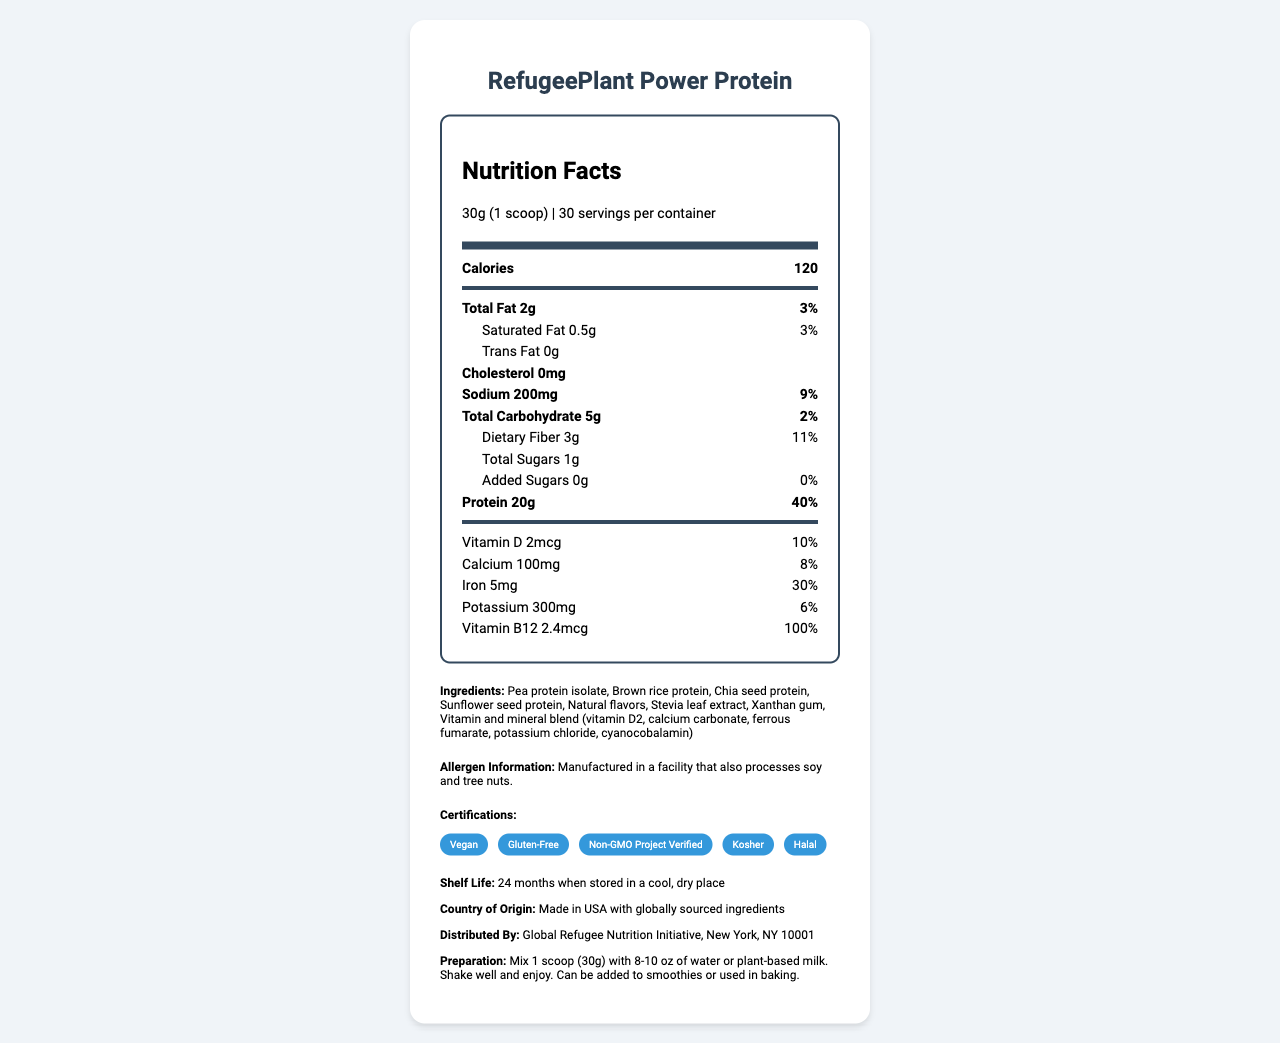what is the serving size of this product? The serving size is clearly stated at the beginning of the Nutrition Facts label.
Answer: 30g (1 scoop) how many calories does one serving contain? The calories per serving are listed right below the serving size information.
Answer: 120 what is the total fat content per serving? The total fat amount is shown directly under the Total Fat label on the Nutrition Facts section.
Answer: 2g which ingredient is listed first in the ingredients list? Pea protein isolate appears first in the list of ingredients.
Answer: Pea protein isolate what percentage of daily value (%DV) does the protein content represent? The daily value percentage for protein is specified next to its amount in the Nutrition Facts section.
Answer: 40% how much dietary fiber is in one serving? The amount of dietary fiber per serving is listed in the Nutrition Facts label.
Answer: 3g does this product contain any cholesterol? (Yes/No) The Nutrition Facts label explicitly states "Cholesterol 0mg".
Answer: No which vitamin has the highest daily value percentage in this product? A. Vitamin D B. Iron C. Vitamin B12 D. Calcium Vitamin B12 has a 100% daily value, which is the highest among the listed vitamins and minerals.
Answer: C. Vitamin B12 what certifications does this product have? A. Vegan B. Gluten-Free C. Non-GMO D. All of the above The certification list includes Vegan, Gluten-Free, Non-GMO Project Verified, Kosher, and Halal.
Answer: D. All of the above what allergens are mentioned in the allergen information? The allergen information mentions that the product is manufactured in a facility that processes soy and tree nuts.
Answer: Soy and tree nuts what is the shelf life of this product? The additional information section states the shelf life detail.
Answer: 24 months when stored in a cool, dry place does this product contain any added sugars? (True/False) The label indicates 0g of added sugars, with 0% daily value.
Answer: False summarize the main nutritional features and additional information of RefugeePlant Power Protein. This summary covers the essential nutritional features and supporting information, highlighting its suitability for refugee dietary needs.
Answer: RefugeePlant Power Protein provides a high amount of protein (20g per serving) and contains essential vitamins and minerals like Iron and Vitamin B12. It is free from cholesterol and added sugars, low in total fat, and includes 3g of dietary fiber. The product is certified Vegan, Gluten-Free, Non-GMO, Kosher, and Halal. It has a shelf life of 24 months. This makes it an ideal option for meeting refugee dietary restrictions while ensuring nutritional adequacy. is this product suitable for people with soy allergies? The allergen information states that it is manufactured in a facility that processes soy, but it does not specify if the product itself contains soy.
Answer: Cannot be determined 